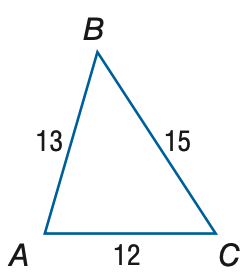Answer the mathemtical geometry problem and directly provide the correct option letter.
Question: Find the measure of \angle A. Round to the nearest degree.
Choices: A: 64 B: 69 C: 74 D: 79 C 